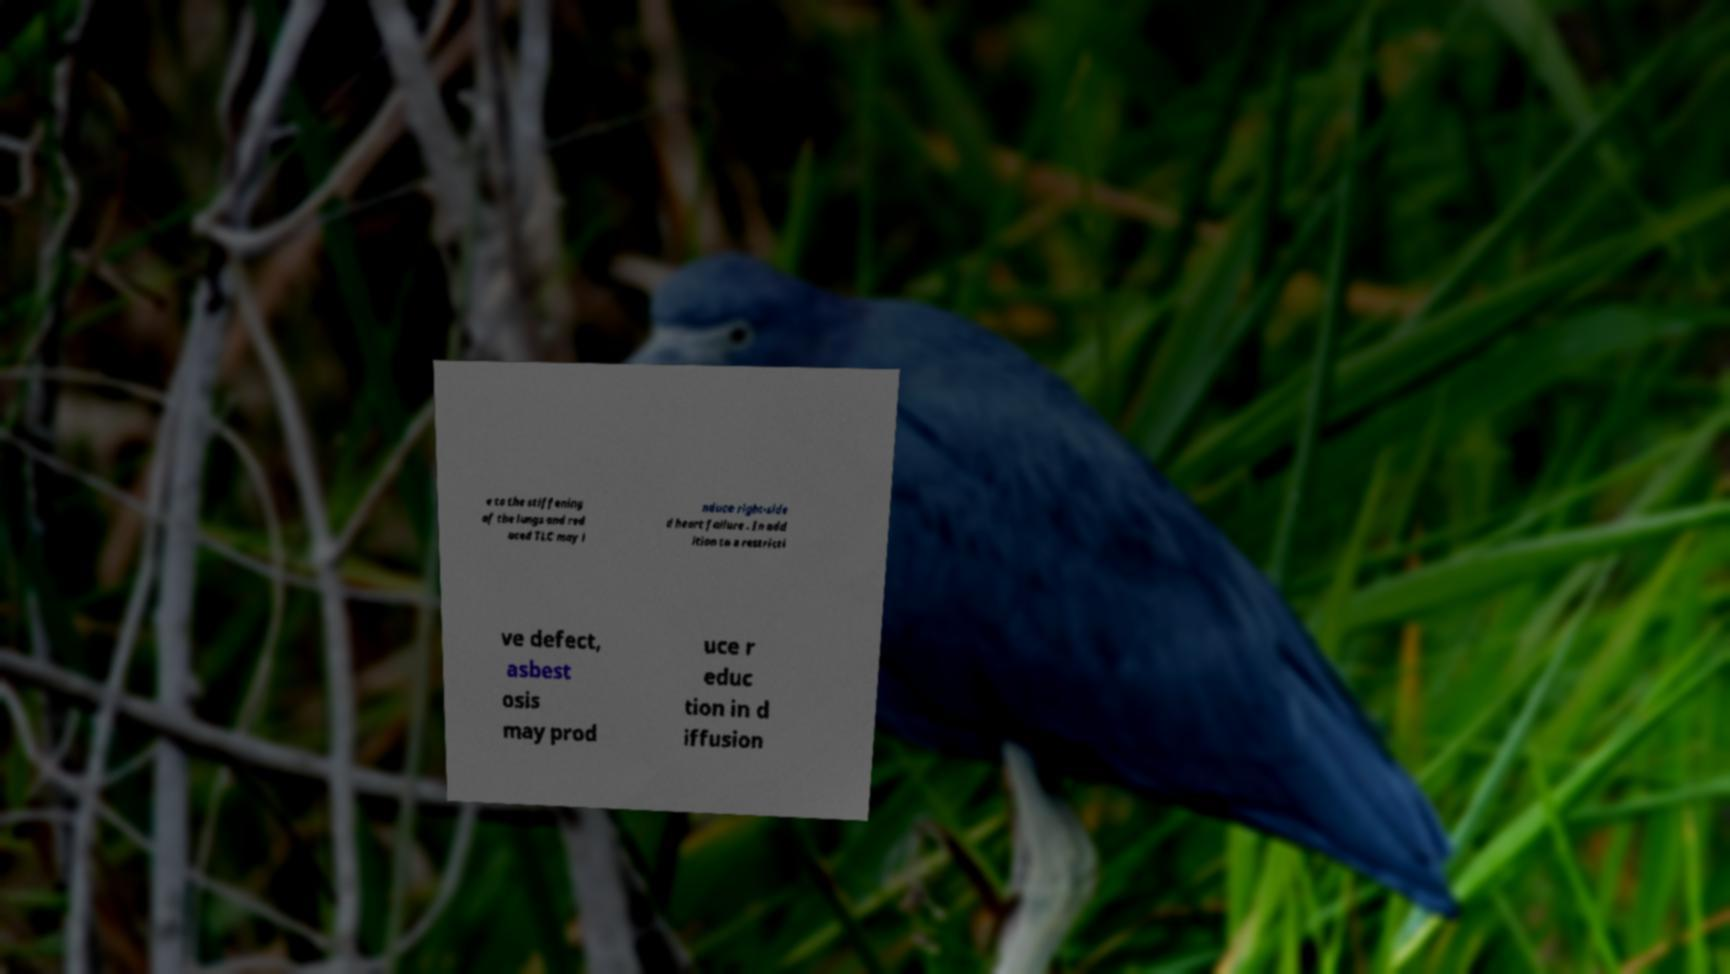For documentation purposes, I need the text within this image transcribed. Could you provide that? e to the stiffening of the lungs and red uced TLC may i nduce right-side d heart failure . In add ition to a restricti ve defect, asbest osis may prod uce r educ tion in d iffusion 